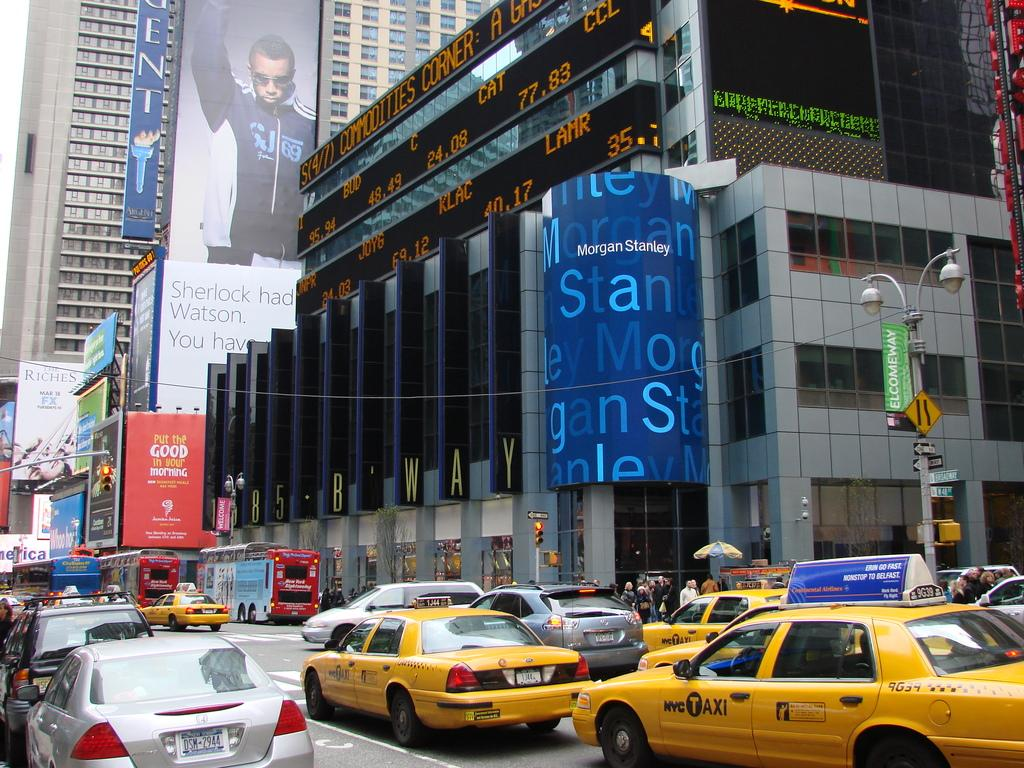<image>
Offer a succinct explanation of the picture presented. A downtown street with NYC Taxi cabs driving down the street. 